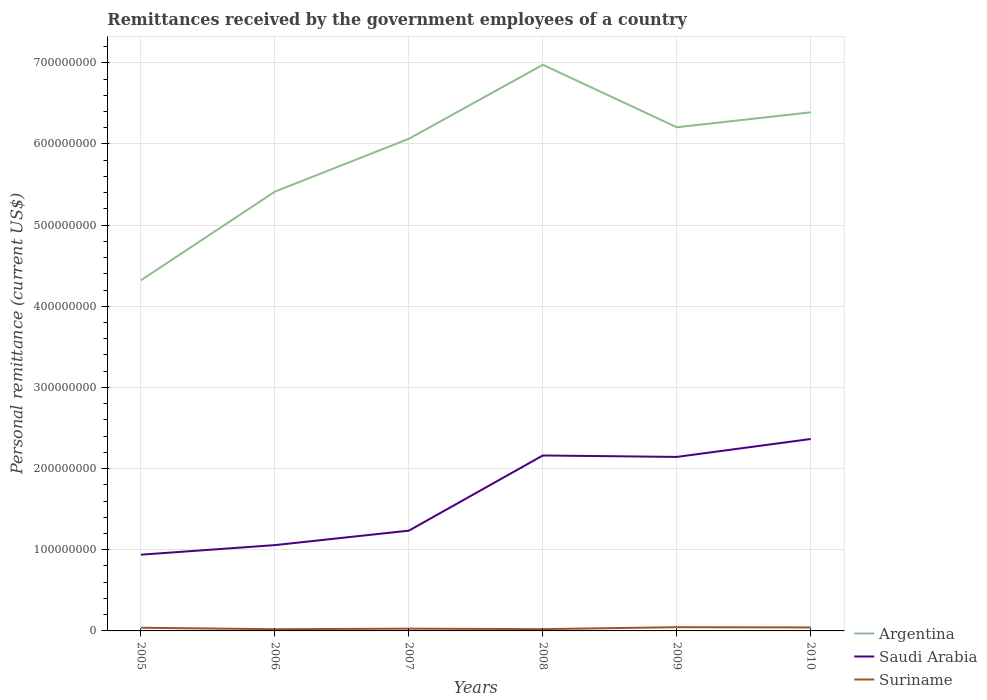Across all years, what is the maximum remittances received by the government employees in Argentina?
Your answer should be compact. 4.32e+08. In which year was the remittances received by the government employees in Saudi Arabia maximum?
Make the answer very short. 2005. What is the total remittances received by the government employees in Saudi Arabia in the graph?
Provide a succinct answer. -1.18e+07. What is the difference between the highest and the second highest remittances received by the government employees in Argentina?
Your answer should be very brief. 2.65e+08. How many legend labels are there?
Ensure brevity in your answer.  3. How are the legend labels stacked?
Provide a short and direct response. Vertical. What is the title of the graph?
Keep it short and to the point. Remittances received by the government employees of a country. What is the label or title of the Y-axis?
Offer a terse response. Personal remittance (current US$). What is the Personal remittance (current US$) of Argentina in 2005?
Give a very brief answer. 4.32e+08. What is the Personal remittance (current US$) of Saudi Arabia in 2005?
Give a very brief answer. 9.39e+07. What is the Personal remittance (current US$) in Suriname in 2005?
Keep it short and to the point. 3.90e+06. What is the Personal remittance (current US$) in Argentina in 2006?
Your response must be concise. 5.41e+08. What is the Personal remittance (current US$) in Saudi Arabia in 2006?
Make the answer very short. 1.06e+08. What is the Personal remittance (current US$) in Suriname in 2006?
Provide a short and direct response. 2.10e+06. What is the Personal remittance (current US$) of Argentina in 2007?
Your response must be concise. 6.06e+08. What is the Personal remittance (current US$) of Saudi Arabia in 2007?
Your answer should be very brief. 1.24e+08. What is the Personal remittance (current US$) in Suriname in 2007?
Make the answer very short. 2.80e+06. What is the Personal remittance (current US$) in Argentina in 2008?
Your answer should be very brief. 6.98e+08. What is the Personal remittance (current US$) of Saudi Arabia in 2008?
Offer a very short reply. 2.16e+08. What is the Personal remittance (current US$) of Suriname in 2008?
Your answer should be compact. 2.20e+06. What is the Personal remittance (current US$) in Argentina in 2009?
Your response must be concise. 6.21e+08. What is the Personal remittance (current US$) of Saudi Arabia in 2009?
Ensure brevity in your answer.  2.14e+08. What is the Personal remittance (current US$) in Suriname in 2009?
Give a very brief answer. 4.60e+06. What is the Personal remittance (current US$) of Argentina in 2010?
Give a very brief answer. 6.39e+08. What is the Personal remittance (current US$) in Saudi Arabia in 2010?
Provide a short and direct response. 2.36e+08. What is the Personal remittance (current US$) in Suriname in 2010?
Keep it short and to the point. 4.30e+06. Across all years, what is the maximum Personal remittance (current US$) in Argentina?
Offer a terse response. 6.98e+08. Across all years, what is the maximum Personal remittance (current US$) in Saudi Arabia?
Offer a terse response. 2.36e+08. Across all years, what is the maximum Personal remittance (current US$) of Suriname?
Your answer should be very brief. 4.60e+06. Across all years, what is the minimum Personal remittance (current US$) in Argentina?
Offer a very short reply. 4.32e+08. Across all years, what is the minimum Personal remittance (current US$) in Saudi Arabia?
Your response must be concise. 9.39e+07. Across all years, what is the minimum Personal remittance (current US$) of Suriname?
Make the answer very short. 2.10e+06. What is the total Personal remittance (current US$) of Argentina in the graph?
Make the answer very short. 3.54e+09. What is the total Personal remittance (current US$) in Saudi Arabia in the graph?
Ensure brevity in your answer.  9.90e+08. What is the total Personal remittance (current US$) of Suriname in the graph?
Provide a succinct answer. 1.99e+07. What is the difference between the Personal remittance (current US$) in Argentina in 2005 and that in 2006?
Give a very brief answer. -1.09e+08. What is the difference between the Personal remittance (current US$) of Saudi Arabia in 2005 and that in 2006?
Give a very brief answer. -1.18e+07. What is the difference between the Personal remittance (current US$) in Suriname in 2005 and that in 2006?
Offer a very short reply. 1.80e+06. What is the difference between the Personal remittance (current US$) in Argentina in 2005 and that in 2007?
Offer a very short reply. -1.74e+08. What is the difference between the Personal remittance (current US$) of Saudi Arabia in 2005 and that in 2007?
Your response must be concise. -2.96e+07. What is the difference between the Personal remittance (current US$) of Suriname in 2005 and that in 2007?
Provide a short and direct response. 1.10e+06. What is the difference between the Personal remittance (current US$) of Argentina in 2005 and that in 2008?
Make the answer very short. -2.65e+08. What is the difference between the Personal remittance (current US$) in Saudi Arabia in 2005 and that in 2008?
Make the answer very short. -1.22e+08. What is the difference between the Personal remittance (current US$) in Suriname in 2005 and that in 2008?
Your answer should be very brief. 1.70e+06. What is the difference between the Personal remittance (current US$) in Argentina in 2005 and that in 2009?
Give a very brief answer. -1.88e+08. What is the difference between the Personal remittance (current US$) in Saudi Arabia in 2005 and that in 2009?
Provide a short and direct response. -1.20e+08. What is the difference between the Personal remittance (current US$) in Suriname in 2005 and that in 2009?
Ensure brevity in your answer.  -7.00e+05. What is the difference between the Personal remittance (current US$) in Argentina in 2005 and that in 2010?
Your response must be concise. -2.07e+08. What is the difference between the Personal remittance (current US$) in Saudi Arabia in 2005 and that in 2010?
Provide a succinct answer. -1.43e+08. What is the difference between the Personal remittance (current US$) of Suriname in 2005 and that in 2010?
Provide a short and direct response. -4.00e+05. What is the difference between the Personal remittance (current US$) in Argentina in 2006 and that in 2007?
Make the answer very short. -6.51e+07. What is the difference between the Personal remittance (current US$) of Saudi Arabia in 2006 and that in 2007?
Provide a succinct answer. -1.78e+07. What is the difference between the Personal remittance (current US$) of Suriname in 2006 and that in 2007?
Give a very brief answer. -7.00e+05. What is the difference between the Personal remittance (current US$) in Argentina in 2006 and that in 2008?
Your response must be concise. -1.56e+08. What is the difference between the Personal remittance (current US$) in Saudi Arabia in 2006 and that in 2008?
Your response must be concise. -1.10e+08. What is the difference between the Personal remittance (current US$) in Argentina in 2006 and that in 2009?
Give a very brief answer. -7.93e+07. What is the difference between the Personal remittance (current US$) of Saudi Arabia in 2006 and that in 2009?
Make the answer very short. -1.09e+08. What is the difference between the Personal remittance (current US$) of Suriname in 2006 and that in 2009?
Make the answer very short. -2.50e+06. What is the difference between the Personal remittance (current US$) of Argentina in 2006 and that in 2010?
Your answer should be very brief. -9.77e+07. What is the difference between the Personal remittance (current US$) of Saudi Arabia in 2006 and that in 2010?
Provide a succinct answer. -1.31e+08. What is the difference between the Personal remittance (current US$) of Suriname in 2006 and that in 2010?
Your response must be concise. -2.20e+06. What is the difference between the Personal remittance (current US$) in Argentina in 2007 and that in 2008?
Offer a terse response. -9.11e+07. What is the difference between the Personal remittance (current US$) of Saudi Arabia in 2007 and that in 2008?
Your answer should be very brief. -9.26e+07. What is the difference between the Personal remittance (current US$) of Suriname in 2007 and that in 2008?
Provide a succinct answer. 6.00e+05. What is the difference between the Personal remittance (current US$) in Argentina in 2007 and that in 2009?
Offer a terse response. -1.42e+07. What is the difference between the Personal remittance (current US$) in Saudi Arabia in 2007 and that in 2009?
Your answer should be compact. -9.09e+07. What is the difference between the Personal remittance (current US$) in Suriname in 2007 and that in 2009?
Your response must be concise. -1.80e+06. What is the difference between the Personal remittance (current US$) of Argentina in 2007 and that in 2010?
Offer a terse response. -3.26e+07. What is the difference between the Personal remittance (current US$) in Saudi Arabia in 2007 and that in 2010?
Your response must be concise. -1.13e+08. What is the difference between the Personal remittance (current US$) in Suriname in 2007 and that in 2010?
Give a very brief answer. -1.50e+06. What is the difference between the Personal remittance (current US$) in Argentina in 2008 and that in 2009?
Your answer should be compact. 7.70e+07. What is the difference between the Personal remittance (current US$) of Saudi Arabia in 2008 and that in 2009?
Keep it short and to the point. 1.79e+06. What is the difference between the Personal remittance (current US$) of Suriname in 2008 and that in 2009?
Make the answer very short. -2.40e+06. What is the difference between the Personal remittance (current US$) of Argentina in 2008 and that in 2010?
Your response must be concise. 5.86e+07. What is the difference between the Personal remittance (current US$) of Saudi Arabia in 2008 and that in 2010?
Make the answer very short. -2.03e+07. What is the difference between the Personal remittance (current US$) of Suriname in 2008 and that in 2010?
Make the answer very short. -2.10e+06. What is the difference between the Personal remittance (current US$) of Argentina in 2009 and that in 2010?
Give a very brief answer. -1.84e+07. What is the difference between the Personal remittance (current US$) of Saudi Arabia in 2009 and that in 2010?
Make the answer very short. -2.21e+07. What is the difference between the Personal remittance (current US$) of Suriname in 2009 and that in 2010?
Your answer should be compact. 3.00e+05. What is the difference between the Personal remittance (current US$) of Argentina in 2005 and the Personal remittance (current US$) of Saudi Arabia in 2006?
Offer a terse response. 3.26e+08. What is the difference between the Personal remittance (current US$) in Argentina in 2005 and the Personal remittance (current US$) in Suriname in 2006?
Give a very brief answer. 4.30e+08. What is the difference between the Personal remittance (current US$) in Saudi Arabia in 2005 and the Personal remittance (current US$) in Suriname in 2006?
Provide a succinct answer. 9.18e+07. What is the difference between the Personal remittance (current US$) of Argentina in 2005 and the Personal remittance (current US$) of Saudi Arabia in 2007?
Your response must be concise. 3.09e+08. What is the difference between the Personal remittance (current US$) of Argentina in 2005 and the Personal remittance (current US$) of Suriname in 2007?
Make the answer very short. 4.29e+08. What is the difference between the Personal remittance (current US$) of Saudi Arabia in 2005 and the Personal remittance (current US$) of Suriname in 2007?
Give a very brief answer. 9.11e+07. What is the difference between the Personal remittance (current US$) of Argentina in 2005 and the Personal remittance (current US$) of Saudi Arabia in 2008?
Offer a terse response. 2.16e+08. What is the difference between the Personal remittance (current US$) in Argentina in 2005 and the Personal remittance (current US$) in Suriname in 2008?
Make the answer very short. 4.30e+08. What is the difference between the Personal remittance (current US$) of Saudi Arabia in 2005 and the Personal remittance (current US$) of Suriname in 2008?
Provide a short and direct response. 9.17e+07. What is the difference between the Personal remittance (current US$) in Argentina in 2005 and the Personal remittance (current US$) in Saudi Arabia in 2009?
Your response must be concise. 2.18e+08. What is the difference between the Personal remittance (current US$) in Argentina in 2005 and the Personal remittance (current US$) in Suriname in 2009?
Give a very brief answer. 4.27e+08. What is the difference between the Personal remittance (current US$) in Saudi Arabia in 2005 and the Personal remittance (current US$) in Suriname in 2009?
Keep it short and to the point. 8.93e+07. What is the difference between the Personal remittance (current US$) of Argentina in 2005 and the Personal remittance (current US$) of Saudi Arabia in 2010?
Offer a very short reply. 1.96e+08. What is the difference between the Personal remittance (current US$) of Argentina in 2005 and the Personal remittance (current US$) of Suriname in 2010?
Keep it short and to the point. 4.28e+08. What is the difference between the Personal remittance (current US$) of Saudi Arabia in 2005 and the Personal remittance (current US$) of Suriname in 2010?
Provide a short and direct response. 8.96e+07. What is the difference between the Personal remittance (current US$) in Argentina in 2006 and the Personal remittance (current US$) in Saudi Arabia in 2007?
Offer a terse response. 4.18e+08. What is the difference between the Personal remittance (current US$) of Argentina in 2006 and the Personal remittance (current US$) of Suriname in 2007?
Ensure brevity in your answer.  5.38e+08. What is the difference between the Personal remittance (current US$) in Saudi Arabia in 2006 and the Personal remittance (current US$) in Suriname in 2007?
Offer a terse response. 1.03e+08. What is the difference between the Personal remittance (current US$) of Argentina in 2006 and the Personal remittance (current US$) of Saudi Arabia in 2008?
Offer a terse response. 3.25e+08. What is the difference between the Personal remittance (current US$) in Argentina in 2006 and the Personal remittance (current US$) in Suriname in 2008?
Your answer should be very brief. 5.39e+08. What is the difference between the Personal remittance (current US$) of Saudi Arabia in 2006 and the Personal remittance (current US$) of Suriname in 2008?
Ensure brevity in your answer.  1.04e+08. What is the difference between the Personal remittance (current US$) in Argentina in 2006 and the Personal remittance (current US$) in Saudi Arabia in 2009?
Make the answer very short. 3.27e+08. What is the difference between the Personal remittance (current US$) in Argentina in 2006 and the Personal remittance (current US$) in Suriname in 2009?
Your answer should be very brief. 5.37e+08. What is the difference between the Personal remittance (current US$) in Saudi Arabia in 2006 and the Personal remittance (current US$) in Suriname in 2009?
Offer a very short reply. 1.01e+08. What is the difference between the Personal remittance (current US$) of Argentina in 2006 and the Personal remittance (current US$) of Saudi Arabia in 2010?
Your answer should be compact. 3.05e+08. What is the difference between the Personal remittance (current US$) in Argentina in 2006 and the Personal remittance (current US$) in Suriname in 2010?
Offer a terse response. 5.37e+08. What is the difference between the Personal remittance (current US$) in Saudi Arabia in 2006 and the Personal remittance (current US$) in Suriname in 2010?
Keep it short and to the point. 1.01e+08. What is the difference between the Personal remittance (current US$) in Argentina in 2007 and the Personal remittance (current US$) in Saudi Arabia in 2008?
Give a very brief answer. 3.90e+08. What is the difference between the Personal remittance (current US$) in Argentina in 2007 and the Personal remittance (current US$) in Suriname in 2008?
Give a very brief answer. 6.04e+08. What is the difference between the Personal remittance (current US$) in Saudi Arabia in 2007 and the Personal remittance (current US$) in Suriname in 2008?
Your answer should be compact. 1.21e+08. What is the difference between the Personal remittance (current US$) of Argentina in 2007 and the Personal remittance (current US$) of Saudi Arabia in 2009?
Your answer should be very brief. 3.92e+08. What is the difference between the Personal remittance (current US$) in Argentina in 2007 and the Personal remittance (current US$) in Suriname in 2009?
Make the answer very short. 6.02e+08. What is the difference between the Personal remittance (current US$) in Saudi Arabia in 2007 and the Personal remittance (current US$) in Suriname in 2009?
Offer a terse response. 1.19e+08. What is the difference between the Personal remittance (current US$) of Argentina in 2007 and the Personal remittance (current US$) of Saudi Arabia in 2010?
Keep it short and to the point. 3.70e+08. What is the difference between the Personal remittance (current US$) of Argentina in 2007 and the Personal remittance (current US$) of Suriname in 2010?
Make the answer very short. 6.02e+08. What is the difference between the Personal remittance (current US$) in Saudi Arabia in 2007 and the Personal remittance (current US$) in Suriname in 2010?
Give a very brief answer. 1.19e+08. What is the difference between the Personal remittance (current US$) of Argentina in 2008 and the Personal remittance (current US$) of Saudi Arabia in 2009?
Ensure brevity in your answer.  4.83e+08. What is the difference between the Personal remittance (current US$) of Argentina in 2008 and the Personal remittance (current US$) of Suriname in 2009?
Make the answer very short. 6.93e+08. What is the difference between the Personal remittance (current US$) in Saudi Arabia in 2008 and the Personal remittance (current US$) in Suriname in 2009?
Offer a terse response. 2.12e+08. What is the difference between the Personal remittance (current US$) of Argentina in 2008 and the Personal remittance (current US$) of Saudi Arabia in 2010?
Ensure brevity in your answer.  4.61e+08. What is the difference between the Personal remittance (current US$) of Argentina in 2008 and the Personal remittance (current US$) of Suriname in 2010?
Your response must be concise. 6.93e+08. What is the difference between the Personal remittance (current US$) in Saudi Arabia in 2008 and the Personal remittance (current US$) in Suriname in 2010?
Ensure brevity in your answer.  2.12e+08. What is the difference between the Personal remittance (current US$) in Argentina in 2009 and the Personal remittance (current US$) in Saudi Arabia in 2010?
Offer a very short reply. 3.84e+08. What is the difference between the Personal remittance (current US$) in Argentina in 2009 and the Personal remittance (current US$) in Suriname in 2010?
Give a very brief answer. 6.16e+08. What is the difference between the Personal remittance (current US$) in Saudi Arabia in 2009 and the Personal remittance (current US$) in Suriname in 2010?
Provide a short and direct response. 2.10e+08. What is the average Personal remittance (current US$) in Argentina per year?
Your answer should be very brief. 5.89e+08. What is the average Personal remittance (current US$) of Saudi Arabia per year?
Your response must be concise. 1.65e+08. What is the average Personal remittance (current US$) of Suriname per year?
Offer a terse response. 3.32e+06. In the year 2005, what is the difference between the Personal remittance (current US$) of Argentina and Personal remittance (current US$) of Saudi Arabia?
Your answer should be very brief. 3.38e+08. In the year 2005, what is the difference between the Personal remittance (current US$) of Argentina and Personal remittance (current US$) of Suriname?
Your response must be concise. 4.28e+08. In the year 2005, what is the difference between the Personal remittance (current US$) in Saudi Arabia and Personal remittance (current US$) in Suriname?
Ensure brevity in your answer.  9.00e+07. In the year 2006, what is the difference between the Personal remittance (current US$) of Argentina and Personal remittance (current US$) of Saudi Arabia?
Keep it short and to the point. 4.36e+08. In the year 2006, what is the difference between the Personal remittance (current US$) of Argentina and Personal remittance (current US$) of Suriname?
Give a very brief answer. 5.39e+08. In the year 2006, what is the difference between the Personal remittance (current US$) in Saudi Arabia and Personal remittance (current US$) in Suriname?
Keep it short and to the point. 1.04e+08. In the year 2007, what is the difference between the Personal remittance (current US$) in Argentina and Personal remittance (current US$) in Saudi Arabia?
Your answer should be very brief. 4.83e+08. In the year 2007, what is the difference between the Personal remittance (current US$) in Argentina and Personal remittance (current US$) in Suriname?
Your response must be concise. 6.04e+08. In the year 2007, what is the difference between the Personal remittance (current US$) of Saudi Arabia and Personal remittance (current US$) of Suriname?
Give a very brief answer. 1.21e+08. In the year 2008, what is the difference between the Personal remittance (current US$) of Argentina and Personal remittance (current US$) of Saudi Arabia?
Ensure brevity in your answer.  4.81e+08. In the year 2008, what is the difference between the Personal remittance (current US$) of Argentina and Personal remittance (current US$) of Suriname?
Your response must be concise. 6.95e+08. In the year 2008, what is the difference between the Personal remittance (current US$) in Saudi Arabia and Personal remittance (current US$) in Suriname?
Provide a short and direct response. 2.14e+08. In the year 2009, what is the difference between the Personal remittance (current US$) in Argentina and Personal remittance (current US$) in Saudi Arabia?
Give a very brief answer. 4.06e+08. In the year 2009, what is the difference between the Personal remittance (current US$) of Argentina and Personal remittance (current US$) of Suriname?
Ensure brevity in your answer.  6.16e+08. In the year 2009, what is the difference between the Personal remittance (current US$) of Saudi Arabia and Personal remittance (current US$) of Suriname?
Make the answer very short. 2.10e+08. In the year 2010, what is the difference between the Personal remittance (current US$) of Argentina and Personal remittance (current US$) of Saudi Arabia?
Provide a short and direct response. 4.03e+08. In the year 2010, what is the difference between the Personal remittance (current US$) in Argentina and Personal remittance (current US$) in Suriname?
Give a very brief answer. 6.35e+08. In the year 2010, what is the difference between the Personal remittance (current US$) in Saudi Arabia and Personal remittance (current US$) in Suriname?
Your answer should be compact. 2.32e+08. What is the ratio of the Personal remittance (current US$) of Argentina in 2005 to that in 2006?
Your answer should be compact. 0.8. What is the ratio of the Personal remittance (current US$) in Saudi Arabia in 2005 to that in 2006?
Keep it short and to the point. 0.89. What is the ratio of the Personal remittance (current US$) in Suriname in 2005 to that in 2006?
Your response must be concise. 1.86. What is the ratio of the Personal remittance (current US$) of Argentina in 2005 to that in 2007?
Provide a short and direct response. 0.71. What is the ratio of the Personal remittance (current US$) of Saudi Arabia in 2005 to that in 2007?
Provide a short and direct response. 0.76. What is the ratio of the Personal remittance (current US$) in Suriname in 2005 to that in 2007?
Ensure brevity in your answer.  1.39. What is the ratio of the Personal remittance (current US$) of Argentina in 2005 to that in 2008?
Ensure brevity in your answer.  0.62. What is the ratio of the Personal remittance (current US$) of Saudi Arabia in 2005 to that in 2008?
Provide a succinct answer. 0.43. What is the ratio of the Personal remittance (current US$) of Suriname in 2005 to that in 2008?
Give a very brief answer. 1.77. What is the ratio of the Personal remittance (current US$) in Argentina in 2005 to that in 2009?
Your answer should be very brief. 0.7. What is the ratio of the Personal remittance (current US$) in Saudi Arabia in 2005 to that in 2009?
Ensure brevity in your answer.  0.44. What is the ratio of the Personal remittance (current US$) in Suriname in 2005 to that in 2009?
Offer a terse response. 0.85. What is the ratio of the Personal remittance (current US$) of Argentina in 2005 to that in 2010?
Provide a succinct answer. 0.68. What is the ratio of the Personal remittance (current US$) in Saudi Arabia in 2005 to that in 2010?
Provide a short and direct response. 0.4. What is the ratio of the Personal remittance (current US$) in Suriname in 2005 to that in 2010?
Offer a terse response. 0.91. What is the ratio of the Personal remittance (current US$) of Argentina in 2006 to that in 2007?
Your answer should be compact. 0.89. What is the ratio of the Personal remittance (current US$) in Saudi Arabia in 2006 to that in 2007?
Your answer should be very brief. 0.86. What is the ratio of the Personal remittance (current US$) of Suriname in 2006 to that in 2007?
Ensure brevity in your answer.  0.75. What is the ratio of the Personal remittance (current US$) in Argentina in 2006 to that in 2008?
Offer a terse response. 0.78. What is the ratio of the Personal remittance (current US$) in Saudi Arabia in 2006 to that in 2008?
Offer a terse response. 0.49. What is the ratio of the Personal remittance (current US$) of Suriname in 2006 to that in 2008?
Provide a short and direct response. 0.95. What is the ratio of the Personal remittance (current US$) of Argentina in 2006 to that in 2009?
Offer a terse response. 0.87. What is the ratio of the Personal remittance (current US$) of Saudi Arabia in 2006 to that in 2009?
Your answer should be very brief. 0.49. What is the ratio of the Personal remittance (current US$) in Suriname in 2006 to that in 2009?
Offer a very short reply. 0.46. What is the ratio of the Personal remittance (current US$) in Argentina in 2006 to that in 2010?
Give a very brief answer. 0.85. What is the ratio of the Personal remittance (current US$) of Saudi Arabia in 2006 to that in 2010?
Your answer should be very brief. 0.45. What is the ratio of the Personal remittance (current US$) of Suriname in 2006 to that in 2010?
Offer a terse response. 0.49. What is the ratio of the Personal remittance (current US$) in Argentina in 2007 to that in 2008?
Offer a very short reply. 0.87. What is the ratio of the Personal remittance (current US$) of Saudi Arabia in 2007 to that in 2008?
Ensure brevity in your answer.  0.57. What is the ratio of the Personal remittance (current US$) of Suriname in 2007 to that in 2008?
Ensure brevity in your answer.  1.27. What is the ratio of the Personal remittance (current US$) in Argentina in 2007 to that in 2009?
Offer a terse response. 0.98. What is the ratio of the Personal remittance (current US$) in Saudi Arabia in 2007 to that in 2009?
Provide a short and direct response. 0.58. What is the ratio of the Personal remittance (current US$) of Suriname in 2007 to that in 2009?
Offer a terse response. 0.61. What is the ratio of the Personal remittance (current US$) of Argentina in 2007 to that in 2010?
Your answer should be compact. 0.95. What is the ratio of the Personal remittance (current US$) of Saudi Arabia in 2007 to that in 2010?
Make the answer very short. 0.52. What is the ratio of the Personal remittance (current US$) of Suriname in 2007 to that in 2010?
Your answer should be compact. 0.65. What is the ratio of the Personal remittance (current US$) of Argentina in 2008 to that in 2009?
Provide a short and direct response. 1.12. What is the ratio of the Personal remittance (current US$) of Saudi Arabia in 2008 to that in 2009?
Provide a short and direct response. 1.01. What is the ratio of the Personal remittance (current US$) in Suriname in 2008 to that in 2009?
Give a very brief answer. 0.48. What is the ratio of the Personal remittance (current US$) of Argentina in 2008 to that in 2010?
Offer a very short reply. 1.09. What is the ratio of the Personal remittance (current US$) of Saudi Arabia in 2008 to that in 2010?
Ensure brevity in your answer.  0.91. What is the ratio of the Personal remittance (current US$) of Suriname in 2008 to that in 2010?
Provide a short and direct response. 0.51. What is the ratio of the Personal remittance (current US$) of Argentina in 2009 to that in 2010?
Your answer should be compact. 0.97. What is the ratio of the Personal remittance (current US$) in Saudi Arabia in 2009 to that in 2010?
Provide a short and direct response. 0.91. What is the ratio of the Personal remittance (current US$) in Suriname in 2009 to that in 2010?
Ensure brevity in your answer.  1.07. What is the difference between the highest and the second highest Personal remittance (current US$) in Argentina?
Ensure brevity in your answer.  5.86e+07. What is the difference between the highest and the second highest Personal remittance (current US$) of Saudi Arabia?
Your response must be concise. 2.03e+07. What is the difference between the highest and the lowest Personal remittance (current US$) in Argentina?
Your response must be concise. 2.65e+08. What is the difference between the highest and the lowest Personal remittance (current US$) of Saudi Arabia?
Give a very brief answer. 1.43e+08. What is the difference between the highest and the lowest Personal remittance (current US$) of Suriname?
Make the answer very short. 2.50e+06. 